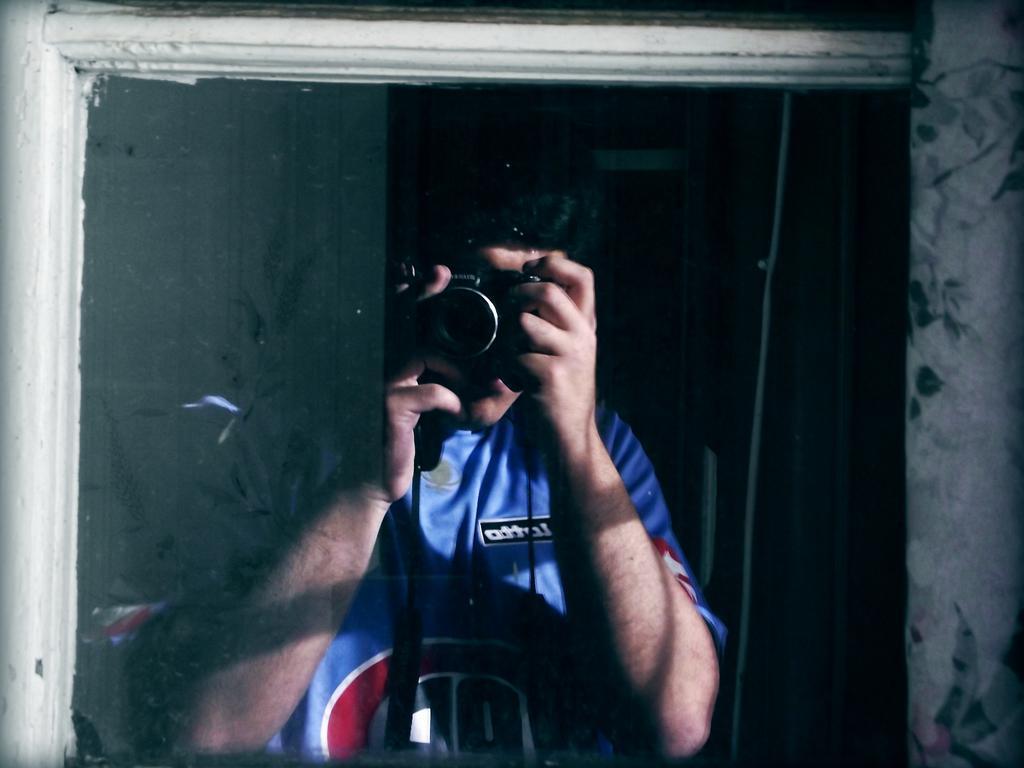How would you summarize this image in a sentence or two? In this image we can see a person holding a camera and taking a photograph, also we can see the background is dark. 